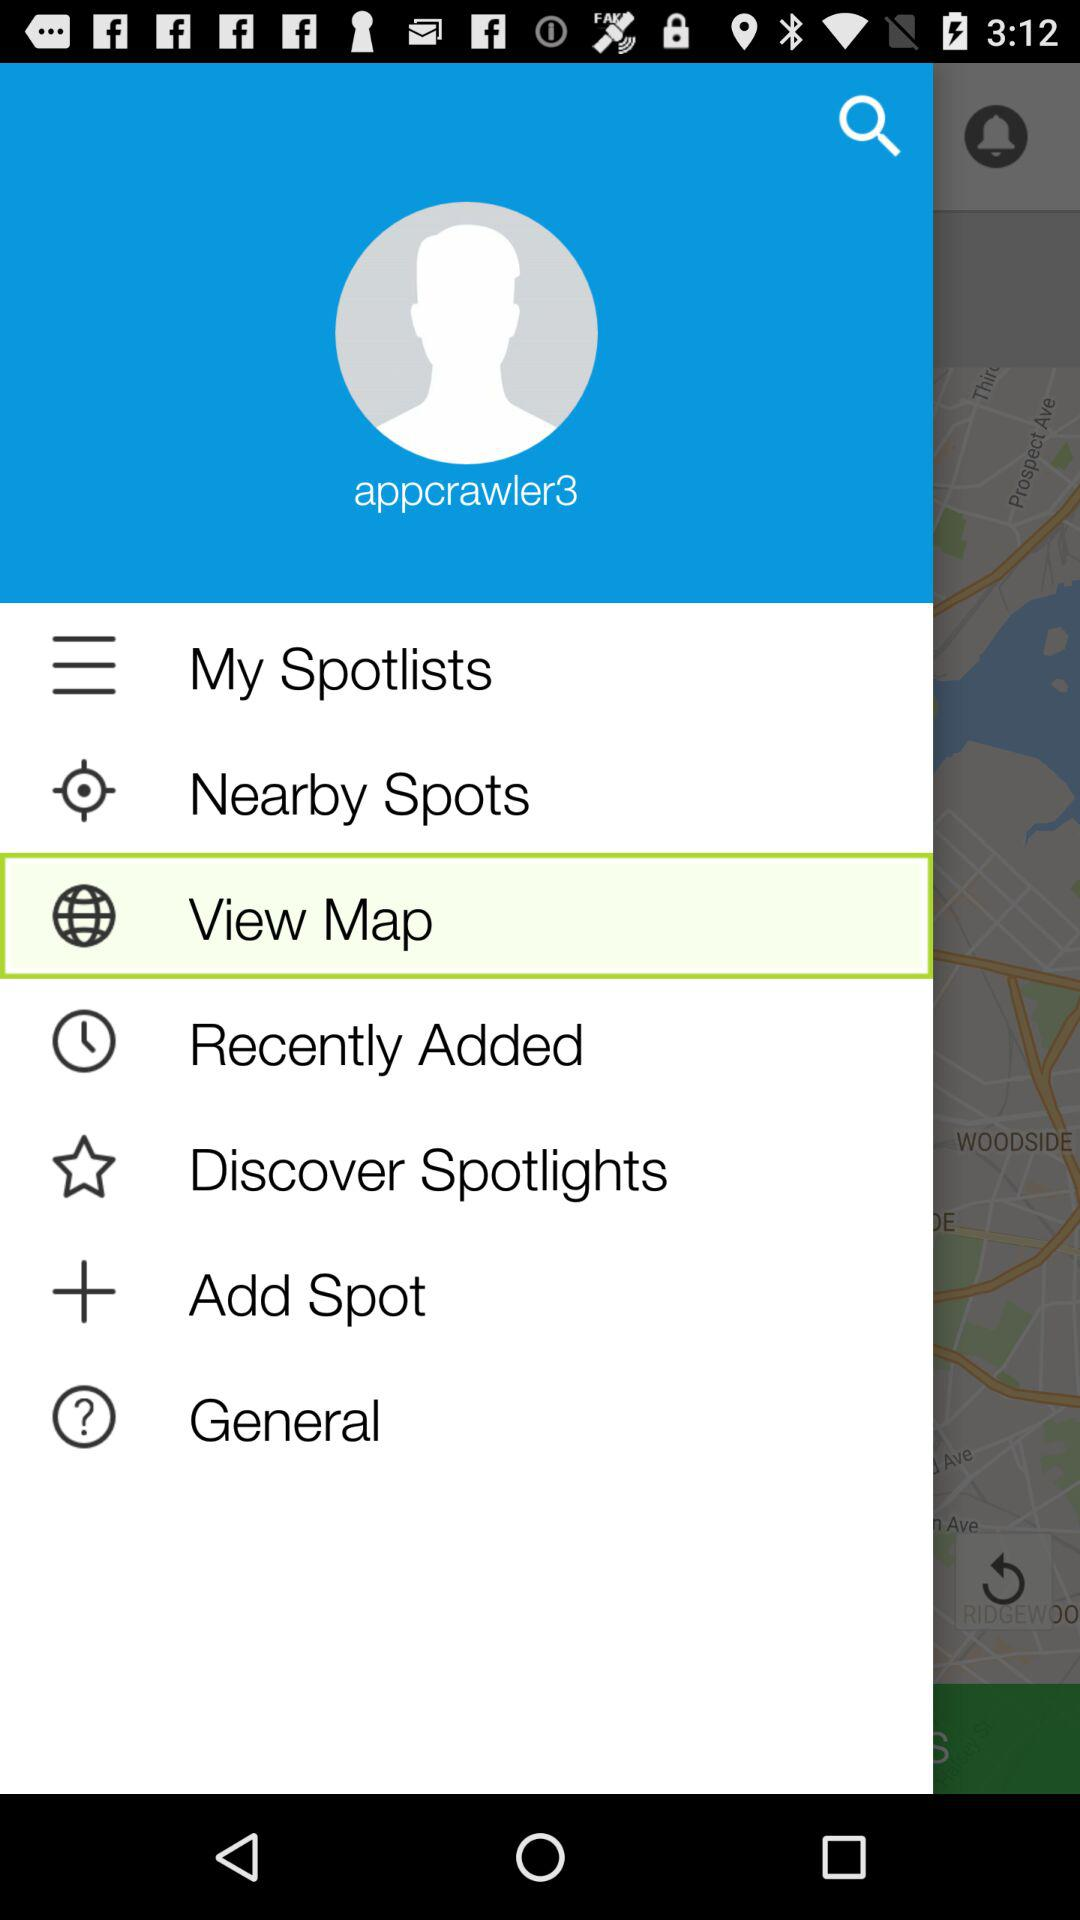What is the username? The username is "appcrawler3". 